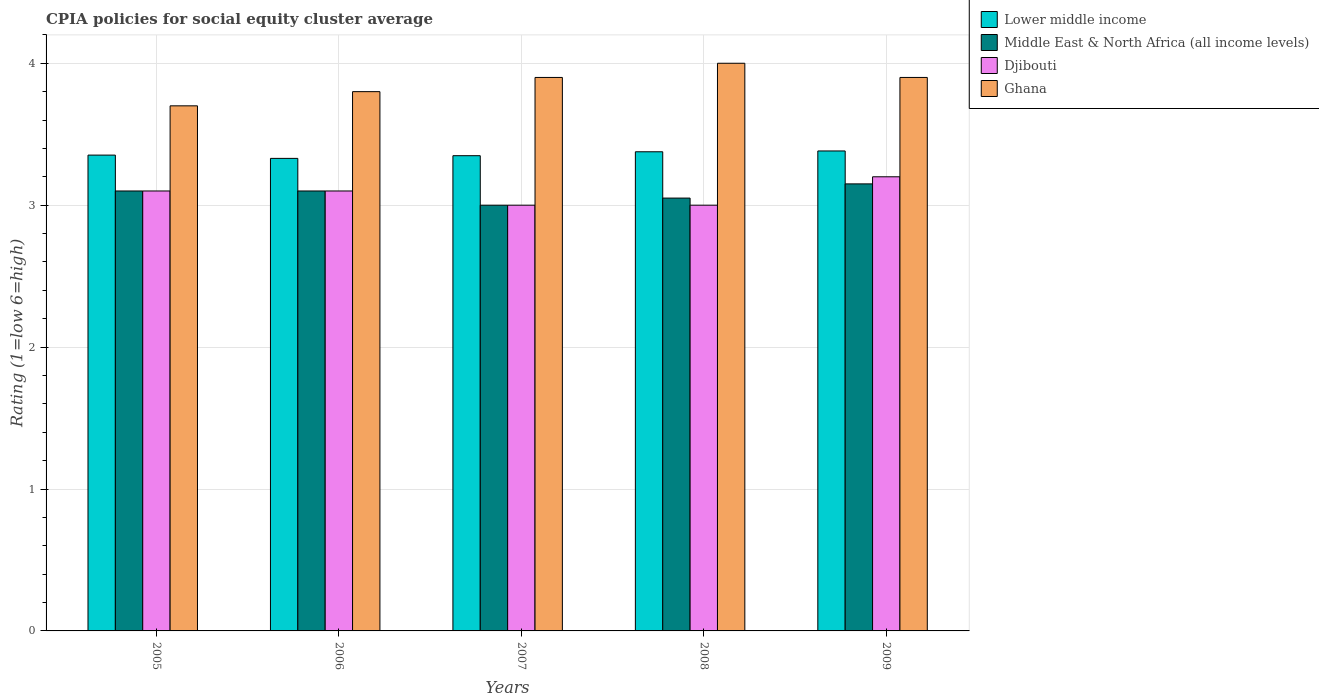How many different coloured bars are there?
Your answer should be compact. 4. How many groups of bars are there?
Your response must be concise. 5. Are the number of bars on each tick of the X-axis equal?
Make the answer very short. Yes. How many bars are there on the 2nd tick from the right?
Offer a very short reply. 4. In how many cases, is the number of bars for a given year not equal to the number of legend labels?
Offer a terse response. 0. Across all years, what is the maximum CPIA rating in Djibouti?
Keep it short and to the point. 3.2. Across all years, what is the minimum CPIA rating in Djibouti?
Provide a short and direct response. 3. In which year was the CPIA rating in Lower middle income maximum?
Your answer should be very brief. 2009. What is the total CPIA rating in Ghana in the graph?
Ensure brevity in your answer.  19.3. What is the difference between the CPIA rating in Lower middle income in 2006 and that in 2008?
Your answer should be very brief. -0.05. What is the difference between the CPIA rating in Lower middle income in 2008 and the CPIA rating in Ghana in 2007?
Offer a terse response. -0.52. What is the average CPIA rating in Lower middle income per year?
Make the answer very short. 3.36. In the year 2008, what is the difference between the CPIA rating in Lower middle income and CPIA rating in Djibouti?
Your response must be concise. 0.38. What is the ratio of the CPIA rating in Ghana in 2005 to that in 2006?
Your answer should be compact. 0.97. Is the difference between the CPIA rating in Lower middle income in 2005 and 2007 greater than the difference between the CPIA rating in Djibouti in 2005 and 2007?
Ensure brevity in your answer.  No. What is the difference between the highest and the second highest CPIA rating in Djibouti?
Offer a terse response. 0.1. What is the difference between the highest and the lowest CPIA rating in Djibouti?
Keep it short and to the point. 0.2. Is it the case that in every year, the sum of the CPIA rating in Ghana and CPIA rating in Middle East & North Africa (all income levels) is greater than the sum of CPIA rating in Lower middle income and CPIA rating in Djibouti?
Give a very brief answer. Yes. What does the 1st bar from the left in 2005 represents?
Keep it short and to the point. Lower middle income. What does the 2nd bar from the right in 2005 represents?
Your answer should be very brief. Djibouti. Is it the case that in every year, the sum of the CPIA rating in Lower middle income and CPIA rating in Ghana is greater than the CPIA rating in Djibouti?
Your response must be concise. Yes. How many bars are there?
Your response must be concise. 20. How many years are there in the graph?
Your answer should be very brief. 5. Are the values on the major ticks of Y-axis written in scientific E-notation?
Your response must be concise. No. Does the graph contain any zero values?
Offer a terse response. No. Does the graph contain grids?
Your answer should be very brief. Yes. Where does the legend appear in the graph?
Ensure brevity in your answer.  Top right. How many legend labels are there?
Your answer should be compact. 4. What is the title of the graph?
Ensure brevity in your answer.  CPIA policies for social equity cluster average. What is the label or title of the Y-axis?
Your response must be concise. Rating (1=low 6=high). What is the Rating (1=low 6=high) in Lower middle income in 2005?
Give a very brief answer. 3.35. What is the Rating (1=low 6=high) of Lower middle income in 2006?
Ensure brevity in your answer.  3.33. What is the Rating (1=low 6=high) of Djibouti in 2006?
Your answer should be compact. 3.1. What is the Rating (1=low 6=high) of Ghana in 2006?
Offer a very short reply. 3.8. What is the Rating (1=low 6=high) in Lower middle income in 2007?
Offer a very short reply. 3.35. What is the Rating (1=low 6=high) in Djibouti in 2007?
Ensure brevity in your answer.  3. What is the Rating (1=low 6=high) in Ghana in 2007?
Provide a short and direct response. 3.9. What is the Rating (1=low 6=high) of Lower middle income in 2008?
Provide a succinct answer. 3.38. What is the Rating (1=low 6=high) in Middle East & North Africa (all income levels) in 2008?
Provide a short and direct response. 3.05. What is the Rating (1=low 6=high) of Ghana in 2008?
Offer a terse response. 4. What is the Rating (1=low 6=high) of Lower middle income in 2009?
Provide a succinct answer. 3.38. What is the Rating (1=low 6=high) of Middle East & North Africa (all income levels) in 2009?
Provide a succinct answer. 3.15. What is the Rating (1=low 6=high) of Djibouti in 2009?
Offer a terse response. 3.2. Across all years, what is the maximum Rating (1=low 6=high) in Lower middle income?
Your answer should be very brief. 3.38. Across all years, what is the maximum Rating (1=low 6=high) in Middle East & North Africa (all income levels)?
Your response must be concise. 3.15. Across all years, what is the minimum Rating (1=low 6=high) of Lower middle income?
Your answer should be compact. 3.33. What is the total Rating (1=low 6=high) of Lower middle income in the graph?
Offer a very short reply. 16.79. What is the total Rating (1=low 6=high) in Djibouti in the graph?
Your answer should be very brief. 15.4. What is the total Rating (1=low 6=high) of Ghana in the graph?
Your answer should be very brief. 19.3. What is the difference between the Rating (1=low 6=high) in Lower middle income in 2005 and that in 2006?
Your answer should be very brief. 0.02. What is the difference between the Rating (1=low 6=high) in Lower middle income in 2005 and that in 2007?
Ensure brevity in your answer.  0. What is the difference between the Rating (1=low 6=high) in Middle East & North Africa (all income levels) in 2005 and that in 2007?
Your answer should be compact. 0.1. What is the difference between the Rating (1=low 6=high) in Ghana in 2005 and that in 2007?
Your response must be concise. -0.2. What is the difference between the Rating (1=low 6=high) in Lower middle income in 2005 and that in 2008?
Offer a very short reply. -0.02. What is the difference between the Rating (1=low 6=high) of Lower middle income in 2005 and that in 2009?
Give a very brief answer. -0.03. What is the difference between the Rating (1=low 6=high) in Djibouti in 2005 and that in 2009?
Keep it short and to the point. -0.1. What is the difference between the Rating (1=low 6=high) of Lower middle income in 2006 and that in 2007?
Offer a terse response. -0.02. What is the difference between the Rating (1=low 6=high) of Djibouti in 2006 and that in 2007?
Ensure brevity in your answer.  0.1. What is the difference between the Rating (1=low 6=high) of Lower middle income in 2006 and that in 2008?
Your answer should be very brief. -0.05. What is the difference between the Rating (1=low 6=high) in Lower middle income in 2006 and that in 2009?
Give a very brief answer. -0.05. What is the difference between the Rating (1=low 6=high) in Middle East & North Africa (all income levels) in 2006 and that in 2009?
Your answer should be very brief. -0.05. What is the difference between the Rating (1=low 6=high) in Djibouti in 2006 and that in 2009?
Provide a succinct answer. -0.1. What is the difference between the Rating (1=low 6=high) in Lower middle income in 2007 and that in 2008?
Your response must be concise. -0.03. What is the difference between the Rating (1=low 6=high) of Middle East & North Africa (all income levels) in 2007 and that in 2008?
Ensure brevity in your answer.  -0.05. What is the difference between the Rating (1=low 6=high) of Lower middle income in 2007 and that in 2009?
Offer a terse response. -0.03. What is the difference between the Rating (1=low 6=high) of Middle East & North Africa (all income levels) in 2007 and that in 2009?
Offer a very short reply. -0.15. What is the difference between the Rating (1=low 6=high) of Ghana in 2007 and that in 2009?
Provide a succinct answer. 0. What is the difference between the Rating (1=low 6=high) in Lower middle income in 2008 and that in 2009?
Keep it short and to the point. -0.01. What is the difference between the Rating (1=low 6=high) of Middle East & North Africa (all income levels) in 2008 and that in 2009?
Offer a very short reply. -0.1. What is the difference between the Rating (1=low 6=high) of Ghana in 2008 and that in 2009?
Give a very brief answer. 0.1. What is the difference between the Rating (1=low 6=high) in Lower middle income in 2005 and the Rating (1=low 6=high) in Middle East & North Africa (all income levels) in 2006?
Keep it short and to the point. 0.25. What is the difference between the Rating (1=low 6=high) in Lower middle income in 2005 and the Rating (1=low 6=high) in Djibouti in 2006?
Your answer should be compact. 0.25. What is the difference between the Rating (1=low 6=high) of Lower middle income in 2005 and the Rating (1=low 6=high) of Ghana in 2006?
Keep it short and to the point. -0.45. What is the difference between the Rating (1=low 6=high) in Middle East & North Africa (all income levels) in 2005 and the Rating (1=low 6=high) in Djibouti in 2006?
Keep it short and to the point. 0. What is the difference between the Rating (1=low 6=high) in Middle East & North Africa (all income levels) in 2005 and the Rating (1=low 6=high) in Ghana in 2006?
Provide a succinct answer. -0.7. What is the difference between the Rating (1=low 6=high) of Djibouti in 2005 and the Rating (1=low 6=high) of Ghana in 2006?
Your response must be concise. -0.7. What is the difference between the Rating (1=low 6=high) of Lower middle income in 2005 and the Rating (1=low 6=high) of Middle East & North Africa (all income levels) in 2007?
Ensure brevity in your answer.  0.35. What is the difference between the Rating (1=low 6=high) of Lower middle income in 2005 and the Rating (1=low 6=high) of Djibouti in 2007?
Make the answer very short. 0.35. What is the difference between the Rating (1=low 6=high) of Lower middle income in 2005 and the Rating (1=low 6=high) of Ghana in 2007?
Provide a succinct answer. -0.55. What is the difference between the Rating (1=low 6=high) in Djibouti in 2005 and the Rating (1=low 6=high) in Ghana in 2007?
Your answer should be compact. -0.8. What is the difference between the Rating (1=low 6=high) in Lower middle income in 2005 and the Rating (1=low 6=high) in Middle East & North Africa (all income levels) in 2008?
Your response must be concise. 0.3. What is the difference between the Rating (1=low 6=high) in Lower middle income in 2005 and the Rating (1=low 6=high) in Djibouti in 2008?
Your response must be concise. 0.35. What is the difference between the Rating (1=low 6=high) in Lower middle income in 2005 and the Rating (1=low 6=high) in Ghana in 2008?
Ensure brevity in your answer.  -0.65. What is the difference between the Rating (1=low 6=high) of Djibouti in 2005 and the Rating (1=low 6=high) of Ghana in 2008?
Make the answer very short. -0.9. What is the difference between the Rating (1=low 6=high) of Lower middle income in 2005 and the Rating (1=low 6=high) of Middle East & North Africa (all income levels) in 2009?
Give a very brief answer. 0.2. What is the difference between the Rating (1=low 6=high) in Lower middle income in 2005 and the Rating (1=low 6=high) in Djibouti in 2009?
Offer a very short reply. 0.15. What is the difference between the Rating (1=low 6=high) of Lower middle income in 2005 and the Rating (1=low 6=high) of Ghana in 2009?
Provide a short and direct response. -0.55. What is the difference between the Rating (1=low 6=high) of Middle East & North Africa (all income levels) in 2005 and the Rating (1=low 6=high) of Djibouti in 2009?
Provide a short and direct response. -0.1. What is the difference between the Rating (1=low 6=high) of Middle East & North Africa (all income levels) in 2005 and the Rating (1=low 6=high) of Ghana in 2009?
Ensure brevity in your answer.  -0.8. What is the difference between the Rating (1=low 6=high) in Djibouti in 2005 and the Rating (1=low 6=high) in Ghana in 2009?
Give a very brief answer. -0.8. What is the difference between the Rating (1=low 6=high) in Lower middle income in 2006 and the Rating (1=low 6=high) in Middle East & North Africa (all income levels) in 2007?
Provide a short and direct response. 0.33. What is the difference between the Rating (1=low 6=high) in Lower middle income in 2006 and the Rating (1=low 6=high) in Djibouti in 2007?
Your answer should be very brief. 0.33. What is the difference between the Rating (1=low 6=high) of Lower middle income in 2006 and the Rating (1=low 6=high) of Ghana in 2007?
Make the answer very short. -0.57. What is the difference between the Rating (1=low 6=high) of Middle East & North Africa (all income levels) in 2006 and the Rating (1=low 6=high) of Djibouti in 2007?
Your answer should be compact. 0.1. What is the difference between the Rating (1=low 6=high) of Lower middle income in 2006 and the Rating (1=low 6=high) of Middle East & North Africa (all income levels) in 2008?
Keep it short and to the point. 0.28. What is the difference between the Rating (1=low 6=high) of Lower middle income in 2006 and the Rating (1=low 6=high) of Djibouti in 2008?
Ensure brevity in your answer.  0.33. What is the difference between the Rating (1=low 6=high) in Lower middle income in 2006 and the Rating (1=low 6=high) in Ghana in 2008?
Give a very brief answer. -0.67. What is the difference between the Rating (1=low 6=high) of Djibouti in 2006 and the Rating (1=low 6=high) of Ghana in 2008?
Offer a very short reply. -0.9. What is the difference between the Rating (1=low 6=high) in Lower middle income in 2006 and the Rating (1=low 6=high) in Middle East & North Africa (all income levels) in 2009?
Offer a very short reply. 0.18. What is the difference between the Rating (1=low 6=high) in Lower middle income in 2006 and the Rating (1=low 6=high) in Djibouti in 2009?
Your answer should be very brief. 0.13. What is the difference between the Rating (1=low 6=high) of Lower middle income in 2006 and the Rating (1=low 6=high) of Ghana in 2009?
Provide a succinct answer. -0.57. What is the difference between the Rating (1=low 6=high) in Middle East & North Africa (all income levels) in 2006 and the Rating (1=low 6=high) in Djibouti in 2009?
Your response must be concise. -0.1. What is the difference between the Rating (1=low 6=high) in Djibouti in 2006 and the Rating (1=low 6=high) in Ghana in 2009?
Ensure brevity in your answer.  -0.8. What is the difference between the Rating (1=low 6=high) of Lower middle income in 2007 and the Rating (1=low 6=high) of Middle East & North Africa (all income levels) in 2008?
Your answer should be very brief. 0.3. What is the difference between the Rating (1=low 6=high) of Lower middle income in 2007 and the Rating (1=low 6=high) of Djibouti in 2008?
Keep it short and to the point. 0.35. What is the difference between the Rating (1=low 6=high) in Lower middle income in 2007 and the Rating (1=low 6=high) in Ghana in 2008?
Your answer should be compact. -0.65. What is the difference between the Rating (1=low 6=high) of Lower middle income in 2007 and the Rating (1=low 6=high) of Middle East & North Africa (all income levels) in 2009?
Your answer should be compact. 0.2. What is the difference between the Rating (1=low 6=high) of Lower middle income in 2007 and the Rating (1=low 6=high) of Djibouti in 2009?
Offer a very short reply. 0.15. What is the difference between the Rating (1=low 6=high) of Lower middle income in 2007 and the Rating (1=low 6=high) of Ghana in 2009?
Your answer should be very brief. -0.55. What is the difference between the Rating (1=low 6=high) in Middle East & North Africa (all income levels) in 2007 and the Rating (1=low 6=high) in Djibouti in 2009?
Offer a very short reply. -0.2. What is the difference between the Rating (1=low 6=high) in Middle East & North Africa (all income levels) in 2007 and the Rating (1=low 6=high) in Ghana in 2009?
Offer a very short reply. -0.9. What is the difference between the Rating (1=low 6=high) of Djibouti in 2007 and the Rating (1=low 6=high) of Ghana in 2009?
Keep it short and to the point. -0.9. What is the difference between the Rating (1=low 6=high) in Lower middle income in 2008 and the Rating (1=low 6=high) in Middle East & North Africa (all income levels) in 2009?
Provide a short and direct response. 0.23. What is the difference between the Rating (1=low 6=high) in Lower middle income in 2008 and the Rating (1=low 6=high) in Djibouti in 2009?
Keep it short and to the point. 0.18. What is the difference between the Rating (1=low 6=high) of Lower middle income in 2008 and the Rating (1=low 6=high) of Ghana in 2009?
Keep it short and to the point. -0.52. What is the difference between the Rating (1=low 6=high) in Middle East & North Africa (all income levels) in 2008 and the Rating (1=low 6=high) in Ghana in 2009?
Provide a succinct answer. -0.85. What is the difference between the Rating (1=low 6=high) in Djibouti in 2008 and the Rating (1=low 6=high) in Ghana in 2009?
Make the answer very short. -0.9. What is the average Rating (1=low 6=high) of Lower middle income per year?
Offer a terse response. 3.36. What is the average Rating (1=low 6=high) of Middle East & North Africa (all income levels) per year?
Ensure brevity in your answer.  3.08. What is the average Rating (1=low 6=high) in Djibouti per year?
Make the answer very short. 3.08. What is the average Rating (1=low 6=high) in Ghana per year?
Your answer should be very brief. 3.86. In the year 2005, what is the difference between the Rating (1=low 6=high) of Lower middle income and Rating (1=low 6=high) of Middle East & North Africa (all income levels)?
Your response must be concise. 0.25. In the year 2005, what is the difference between the Rating (1=low 6=high) in Lower middle income and Rating (1=low 6=high) in Djibouti?
Offer a terse response. 0.25. In the year 2005, what is the difference between the Rating (1=low 6=high) of Lower middle income and Rating (1=low 6=high) of Ghana?
Your answer should be compact. -0.35. In the year 2005, what is the difference between the Rating (1=low 6=high) in Djibouti and Rating (1=low 6=high) in Ghana?
Make the answer very short. -0.6. In the year 2006, what is the difference between the Rating (1=low 6=high) in Lower middle income and Rating (1=low 6=high) in Middle East & North Africa (all income levels)?
Offer a terse response. 0.23. In the year 2006, what is the difference between the Rating (1=low 6=high) of Lower middle income and Rating (1=low 6=high) of Djibouti?
Your answer should be compact. 0.23. In the year 2006, what is the difference between the Rating (1=low 6=high) in Lower middle income and Rating (1=low 6=high) in Ghana?
Your response must be concise. -0.47. In the year 2006, what is the difference between the Rating (1=low 6=high) of Middle East & North Africa (all income levels) and Rating (1=low 6=high) of Djibouti?
Give a very brief answer. 0. In the year 2006, what is the difference between the Rating (1=low 6=high) of Djibouti and Rating (1=low 6=high) of Ghana?
Your answer should be very brief. -0.7. In the year 2007, what is the difference between the Rating (1=low 6=high) in Lower middle income and Rating (1=low 6=high) in Middle East & North Africa (all income levels)?
Ensure brevity in your answer.  0.35. In the year 2007, what is the difference between the Rating (1=low 6=high) of Lower middle income and Rating (1=low 6=high) of Djibouti?
Ensure brevity in your answer.  0.35. In the year 2007, what is the difference between the Rating (1=low 6=high) in Lower middle income and Rating (1=low 6=high) in Ghana?
Provide a succinct answer. -0.55. In the year 2007, what is the difference between the Rating (1=low 6=high) in Djibouti and Rating (1=low 6=high) in Ghana?
Your response must be concise. -0.9. In the year 2008, what is the difference between the Rating (1=low 6=high) of Lower middle income and Rating (1=low 6=high) of Middle East & North Africa (all income levels)?
Your response must be concise. 0.33. In the year 2008, what is the difference between the Rating (1=low 6=high) of Lower middle income and Rating (1=low 6=high) of Djibouti?
Give a very brief answer. 0.38. In the year 2008, what is the difference between the Rating (1=low 6=high) in Lower middle income and Rating (1=low 6=high) in Ghana?
Offer a terse response. -0.62. In the year 2008, what is the difference between the Rating (1=low 6=high) in Middle East & North Africa (all income levels) and Rating (1=low 6=high) in Ghana?
Ensure brevity in your answer.  -0.95. In the year 2008, what is the difference between the Rating (1=low 6=high) of Djibouti and Rating (1=low 6=high) of Ghana?
Offer a terse response. -1. In the year 2009, what is the difference between the Rating (1=low 6=high) in Lower middle income and Rating (1=low 6=high) in Middle East & North Africa (all income levels)?
Ensure brevity in your answer.  0.23. In the year 2009, what is the difference between the Rating (1=low 6=high) of Lower middle income and Rating (1=low 6=high) of Djibouti?
Your answer should be compact. 0.18. In the year 2009, what is the difference between the Rating (1=low 6=high) of Lower middle income and Rating (1=low 6=high) of Ghana?
Offer a very short reply. -0.52. In the year 2009, what is the difference between the Rating (1=low 6=high) in Middle East & North Africa (all income levels) and Rating (1=low 6=high) in Djibouti?
Give a very brief answer. -0.05. In the year 2009, what is the difference between the Rating (1=low 6=high) of Middle East & North Africa (all income levels) and Rating (1=low 6=high) of Ghana?
Offer a very short reply. -0.75. In the year 2009, what is the difference between the Rating (1=low 6=high) in Djibouti and Rating (1=low 6=high) in Ghana?
Your response must be concise. -0.7. What is the ratio of the Rating (1=low 6=high) in Ghana in 2005 to that in 2006?
Keep it short and to the point. 0.97. What is the ratio of the Rating (1=low 6=high) in Middle East & North Africa (all income levels) in 2005 to that in 2007?
Offer a terse response. 1.03. What is the ratio of the Rating (1=low 6=high) of Ghana in 2005 to that in 2007?
Make the answer very short. 0.95. What is the ratio of the Rating (1=low 6=high) of Lower middle income in 2005 to that in 2008?
Offer a terse response. 0.99. What is the ratio of the Rating (1=low 6=high) in Middle East & North Africa (all income levels) in 2005 to that in 2008?
Keep it short and to the point. 1.02. What is the ratio of the Rating (1=low 6=high) in Ghana in 2005 to that in 2008?
Your response must be concise. 0.93. What is the ratio of the Rating (1=low 6=high) in Middle East & North Africa (all income levels) in 2005 to that in 2009?
Provide a succinct answer. 0.98. What is the ratio of the Rating (1=low 6=high) of Djibouti in 2005 to that in 2009?
Keep it short and to the point. 0.97. What is the ratio of the Rating (1=low 6=high) of Ghana in 2005 to that in 2009?
Make the answer very short. 0.95. What is the ratio of the Rating (1=low 6=high) of Middle East & North Africa (all income levels) in 2006 to that in 2007?
Keep it short and to the point. 1.03. What is the ratio of the Rating (1=low 6=high) of Ghana in 2006 to that in 2007?
Offer a very short reply. 0.97. What is the ratio of the Rating (1=low 6=high) in Lower middle income in 2006 to that in 2008?
Offer a terse response. 0.99. What is the ratio of the Rating (1=low 6=high) in Middle East & North Africa (all income levels) in 2006 to that in 2008?
Provide a short and direct response. 1.02. What is the ratio of the Rating (1=low 6=high) of Ghana in 2006 to that in 2008?
Give a very brief answer. 0.95. What is the ratio of the Rating (1=low 6=high) in Lower middle income in 2006 to that in 2009?
Your answer should be very brief. 0.98. What is the ratio of the Rating (1=low 6=high) of Middle East & North Africa (all income levels) in 2006 to that in 2009?
Provide a succinct answer. 0.98. What is the ratio of the Rating (1=low 6=high) of Djibouti in 2006 to that in 2009?
Your answer should be very brief. 0.97. What is the ratio of the Rating (1=low 6=high) of Ghana in 2006 to that in 2009?
Provide a short and direct response. 0.97. What is the ratio of the Rating (1=low 6=high) of Lower middle income in 2007 to that in 2008?
Make the answer very short. 0.99. What is the ratio of the Rating (1=low 6=high) of Middle East & North Africa (all income levels) in 2007 to that in 2008?
Make the answer very short. 0.98. What is the ratio of the Rating (1=low 6=high) of Djibouti in 2007 to that in 2008?
Provide a short and direct response. 1. What is the ratio of the Rating (1=low 6=high) in Middle East & North Africa (all income levels) in 2007 to that in 2009?
Offer a terse response. 0.95. What is the ratio of the Rating (1=low 6=high) of Middle East & North Africa (all income levels) in 2008 to that in 2009?
Provide a short and direct response. 0.97. What is the ratio of the Rating (1=low 6=high) in Djibouti in 2008 to that in 2009?
Your answer should be very brief. 0.94. What is the ratio of the Rating (1=low 6=high) in Ghana in 2008 to that in 2009?
Provide a short and direct response. 1.03. What is the difference between the highest and the second highest Rating (1=low 6=high) in Lower middle income?
Offer a terse response. 0.01. What is the difference between the highest and the second highest Rating (1=low 6=high) of Djibouti?
Offer a very short reply. 0.1. What is the difference between the highest and the lowest Rating (1=low 6=high) of Lower middle income?
Offer a terse response. 0.05. What is the difference between the highest and the lowest Rating (1=low 6=high) of Djibouti?
Give a very brief answer. 0.2. 